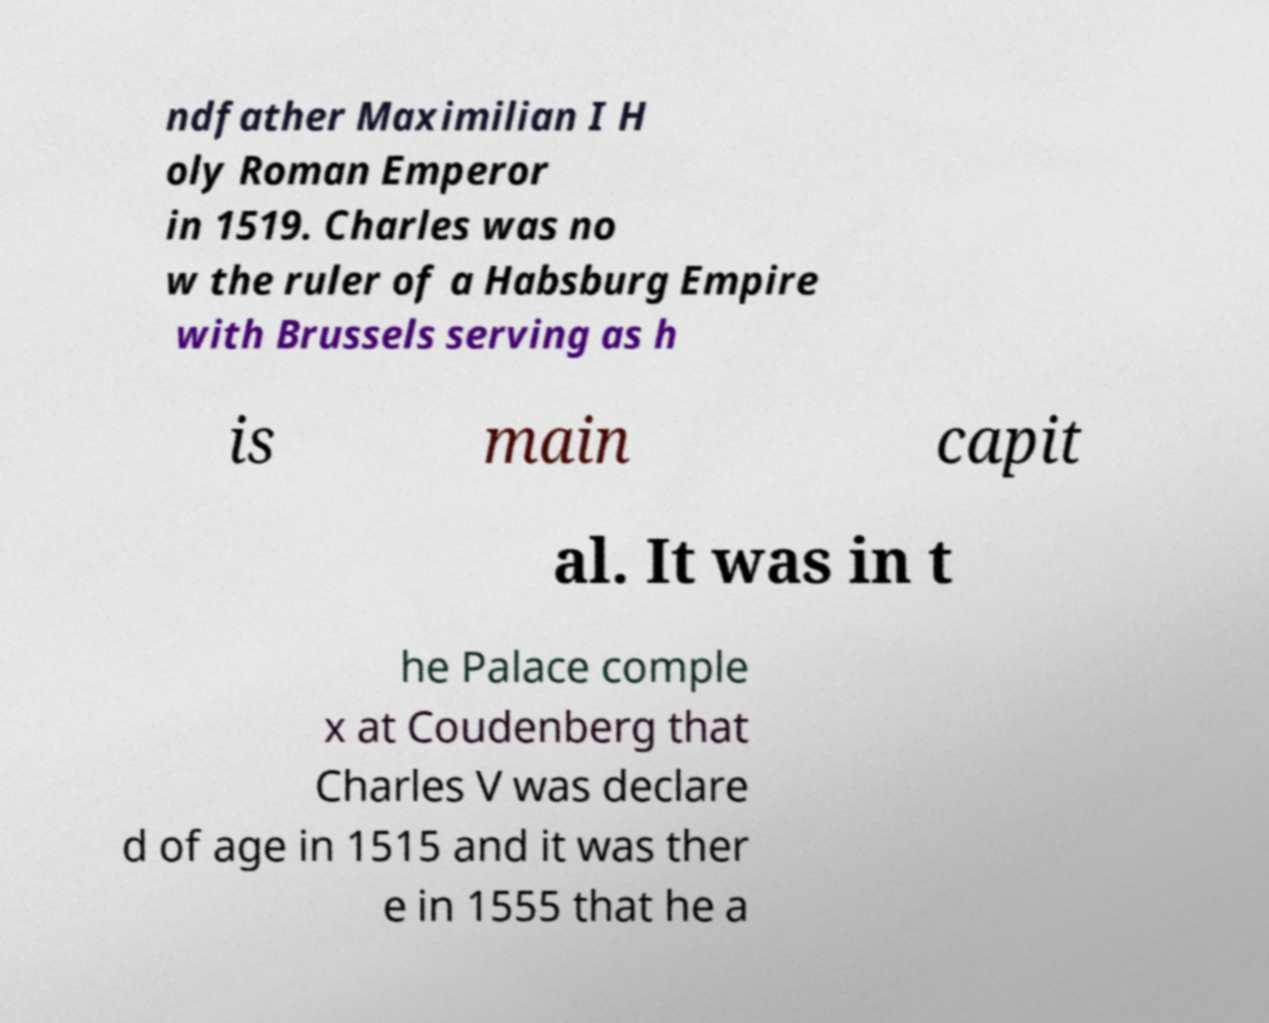There's text embedded in this image that I need extracted. Can you transcribe it verbatim? ndfather Maximilian I H oly Roman Emperor in 1519. Charles was no w the ruler of a Habsburg Empire with Brussels serving as h is main capit al. It was in t he Palace comple x at Coudenberg that Charles V was declare d of age in 1515 and it was ther e in 1555 that he a 